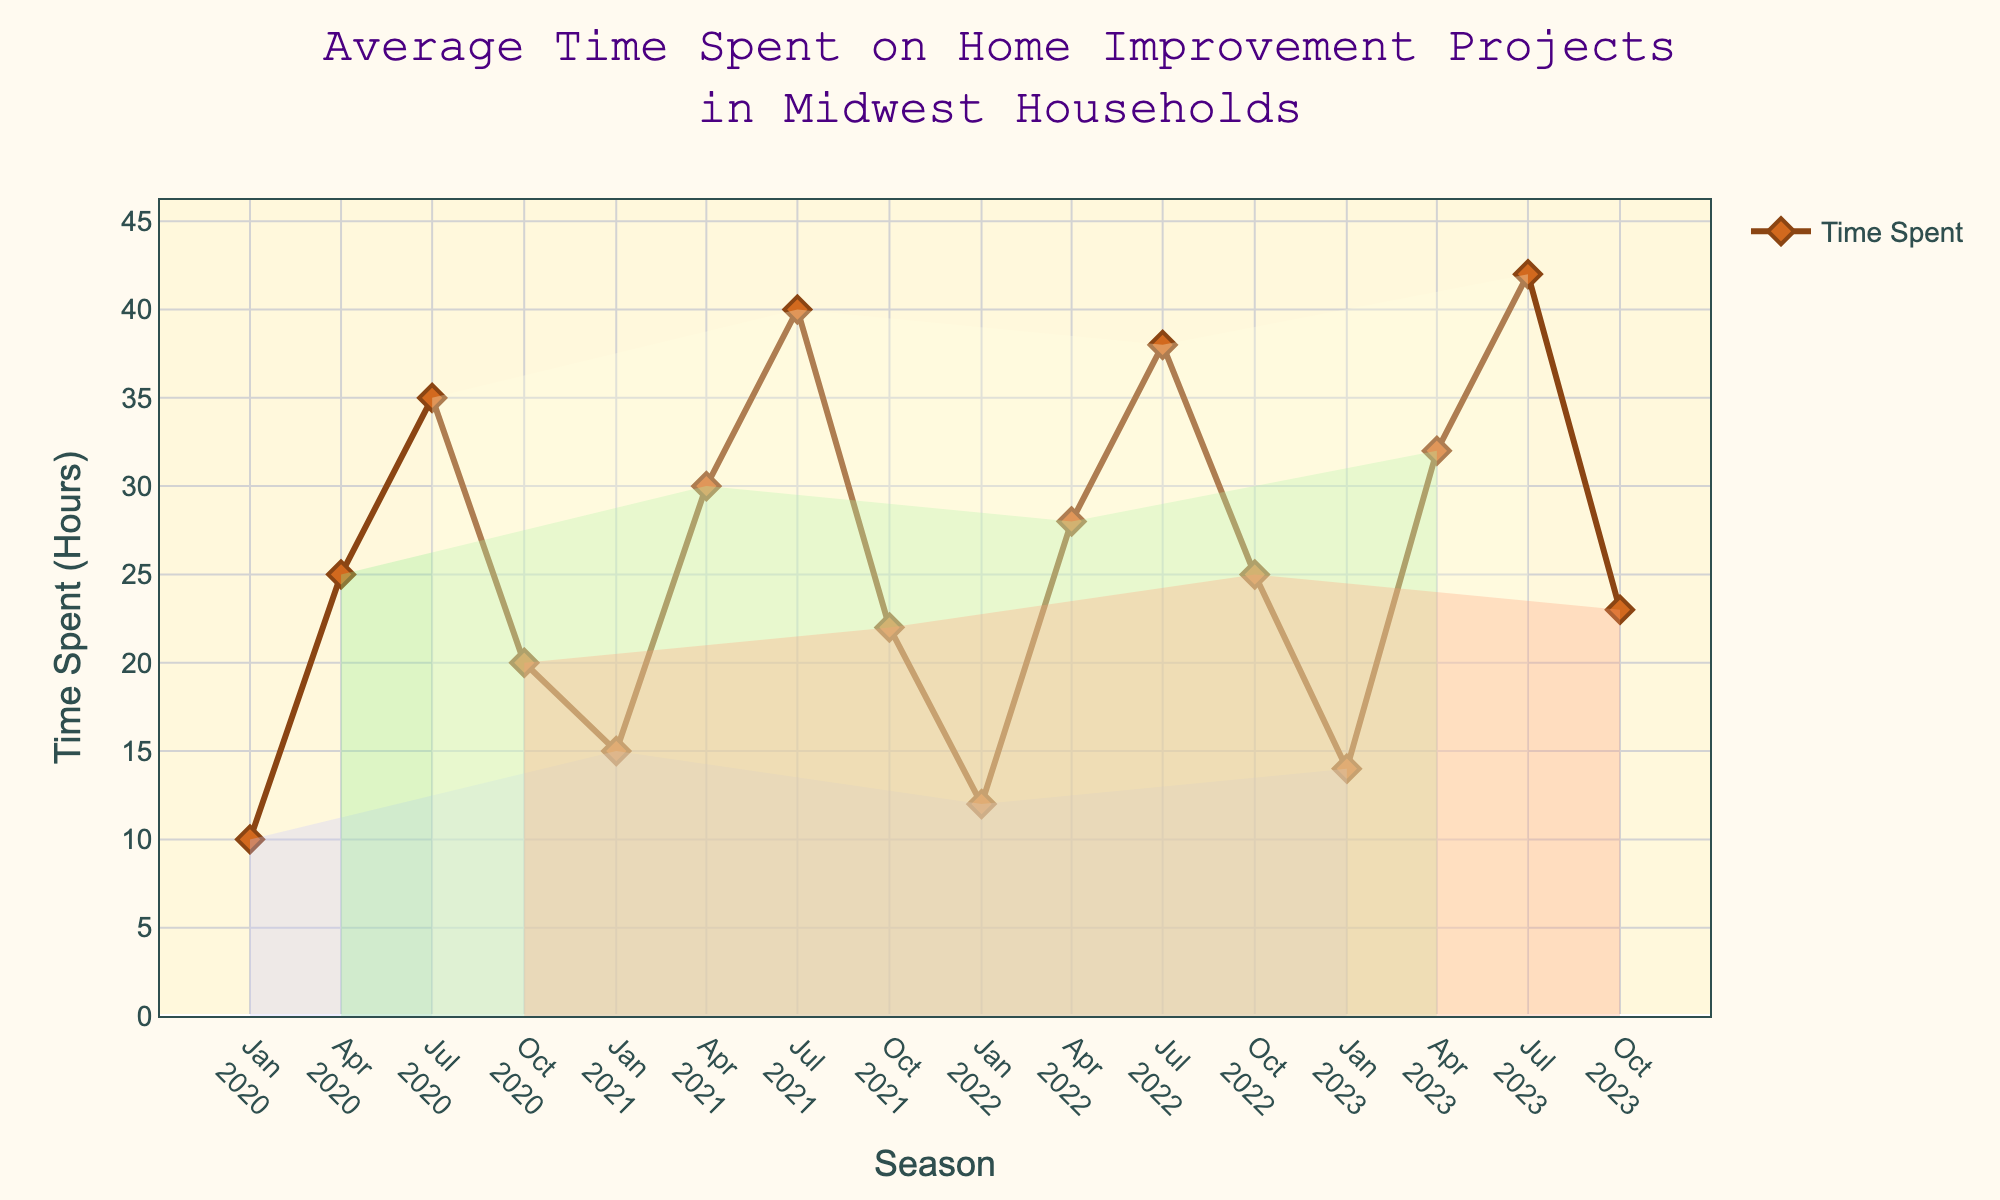What is the title of the plot? The title of the plot is usually displayed at the top center of the figure. In this case, it reads "Average Time Spent on Home Improvement Projects in Midwest Households".
Answer: Average Time Spent on Home Improvement Projects in Midwest Households What is the average time spent on home improvement projects during Spring seasons from 2020 to 2023? To compute the average, add the hours spent each Spring (25 + 30 + 28 + 32) and then divide by the number of Spring seasons (4). The total is 115 hours, so the average is 115 / 4 = 28.75 hours.
Answer: 28.75 hours Which season in 2022 saw the highest time spent on home improvement projects? Look at the data points for each season in 2022 and compare their heights. The Summer 2022 data point is the highest at 38 hours.
Answer: Summer How did the time spent in Fall 2023 compare to that in Fall 2022? Check the data points for Fall 2022 and Fall 2023. Fall 2023 is 23 hours and Fall 2022 is 25 hours. Fall 2023 is 2 hours less than Fall 2022.
Answer: 2 hours less What color is used to fill the background for Winter seasons? The background color for Winter is a pale blue shade, indicative of cold weather. Look for the corresponding shaded regions on the plot.
Answer: Pale blue During which season is the smallest increase in average time spent noticeable between consecutive years? To determine this, compare the year-over-year differences within each season. The smallest increase is seen between Winter 2020 (10 hours) and Winter 2021 (15 hours), which is 5 hours.
Answer: Winter What is the range of time spent on home improvement projects from the plot? The range is the difference between the maximum and minimum values observed. The minimum is 10 hours (Winter 2020), and the maximum is 42 hours (Summer 2023). So, the range is 42 - 10 = 32 hours.
Answer: 32 hours Are there any noticeable trends in how the average time spent on home improvement projects changes from Winter to Summer within a single year? Generally, there's an upward trend from Winter through Spring to Summer within each year. For example, in 2023, the hours went from 14 (Winter) to 32 (Spring) to 42 (Summer).
Answer: Upward trend Which season had the most consistent time spent over the years, and what indicates this consistency? Examine time-spent fluctuations for each season across the years. Spring is the most consistent, with hours ranging from 25 to 32, which is a narrow range relative to other seasons.
Answer: Spring How did the time spent during Summer 2021 compare to Summer 2023? Look at the Summer 2021 data point (40 hours) and the Summer 2023 data point (42 hours). Summer 2023 had 2 hours more than Summer 2021.
Answer: 2 hours more 